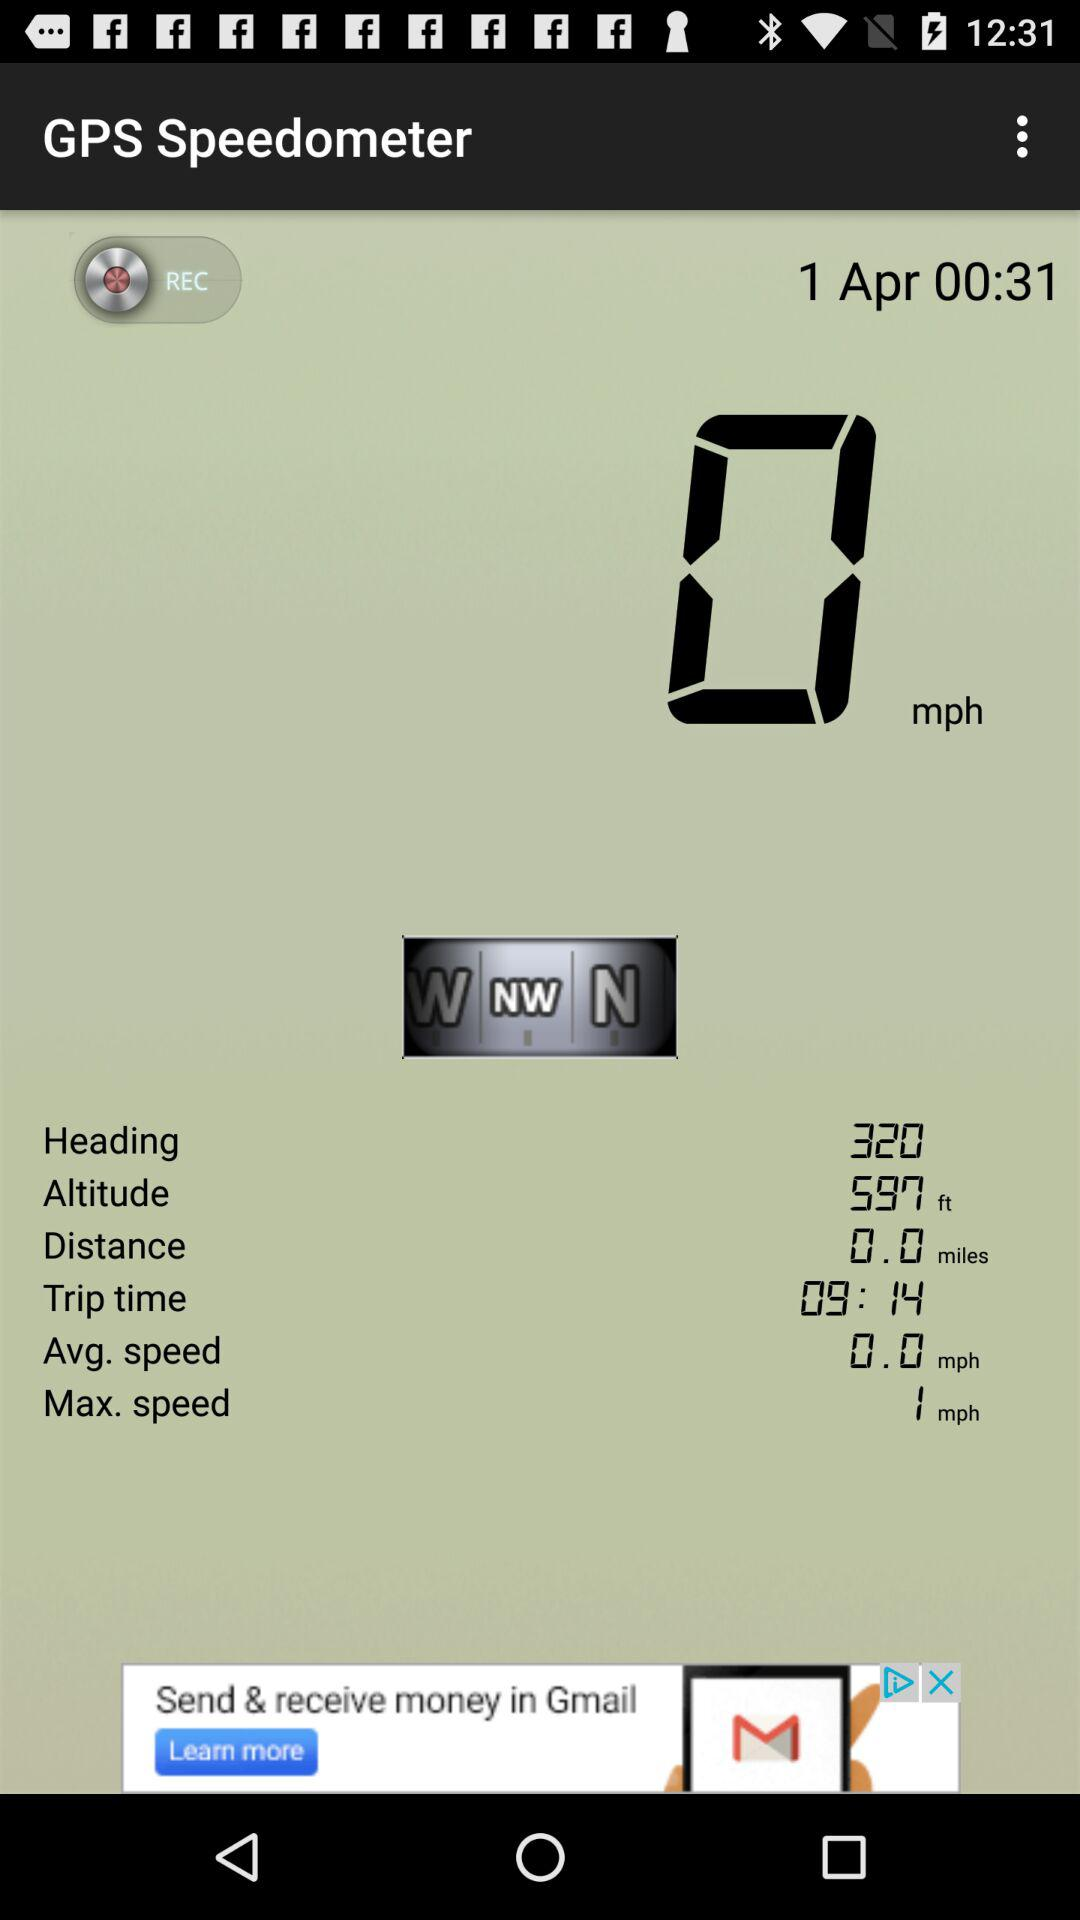What is the average speed? The average speed is 0.0 mph. 